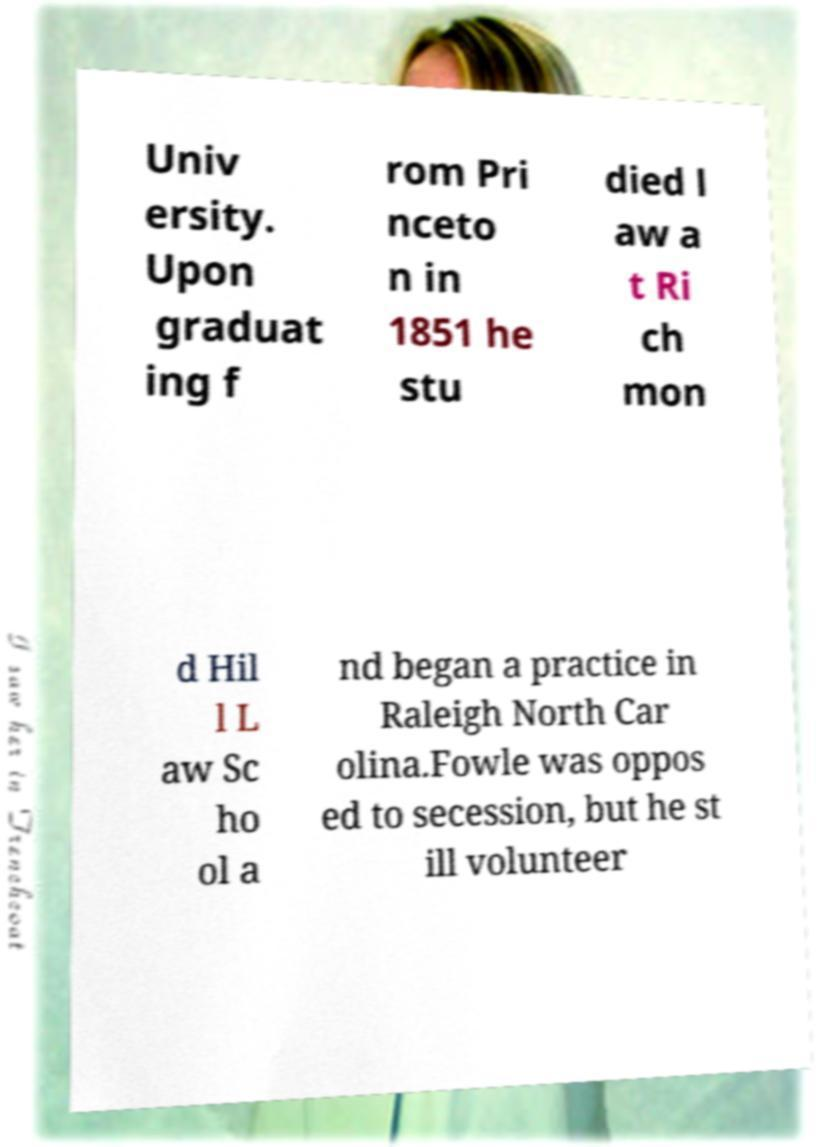I need the written content from this picture converted into text. Can you do that? Univ ersity. Upon graduat ing f rom Pri nceto n in 1851 he stu died l aw a t Ri ch mon d Hil l L aw Sc ho ol a nd began a practice in Raleigh North Car olina.Fowle was oppos ed to secession, but he st ill volunteer 